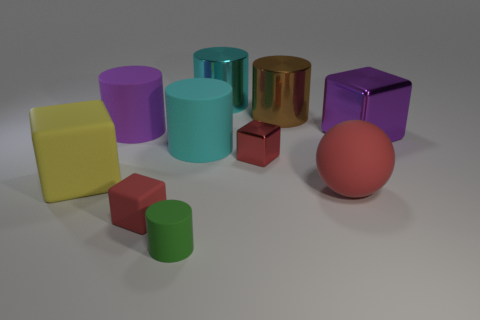Subtract all brown cylinders. How many cylinders are left? 4 Subtract all tiny cylinders. How many cylinders are left? 4 Subtract 1 cylinders. How many cylinders are left? 4 Subtract all blue cubes. Subtract all green cylinders. How many cubes are left? 4 Subtract all balls. How many objects are left? 9 Subtract all tiny red metal cylinders. Subtract all large metal cylinders. How many objects are left? 8 Add 1 small red rubber cubes. How many small red rubber cubes are left? 2 Add 3 cyan cylinders. How many cyan cylinders exist? 5 Subtract 1 yellow cubes. How many objects are left? 9 